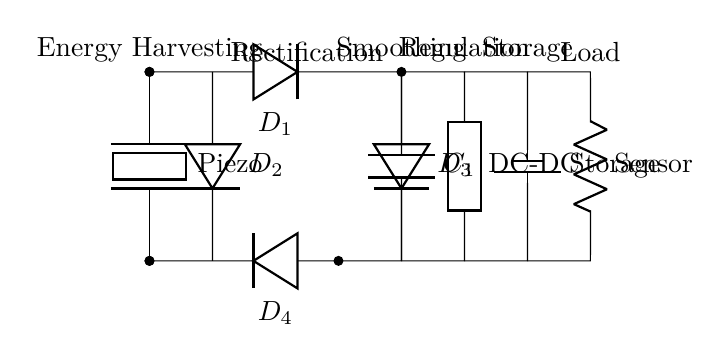What type of energy does this circuit harvest? The circuit harvests mechanical energy, which is converted into electrical energy by the piezoelectric element. This element generates voltage when subjected to mechanical stress.
Answer: Mechanical How many diodes are used in the bridge rectifier? The circuit contains four diodes (D1, D2, D3, and D4) arranged specifically to form a bridge rectifier configuration, allowing current to flow in one direction and convert AC to DC.
Answer: Four What component is used for energy storage? The component used for energy storage in this circuit is a battery, as indicated in the section labeled 'Storage.' The battery is responsible for storing the generated electrical energy for later use.
Answer: Battery What happens after the smoothing capacitor in the circuit? After the smoothing capacitor (C1), the circuit contains a DC-DC converter that regulates the voltage to a stable level suitable for powering the load. This converter minimizes fluctuations in voltage that may affect the performance of the sensor.
Answer: DC-DC converter What is the function of the piezoelectric element? The function of the piezoelectric element is to convert mechanical energy from vibrations or impacts into electrical energy, which is essential for the self-powered operation of the entire circuit.
Answer: Energy conversion What is the load connected to the energy storage? The load connected to the energy storage is labeled as 'Sensor,' indicating that the stored energy is used to power a sensor device that presumably measures a physical parameter or environmental condition.
Answer: Sensor 